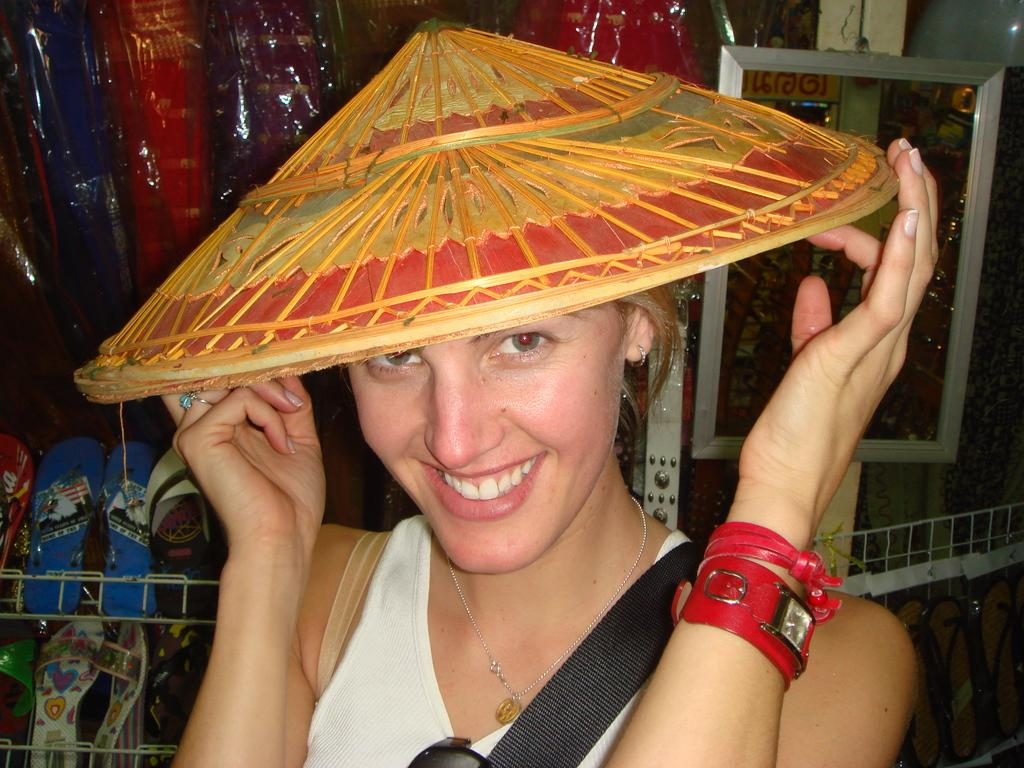Who is present in the image? There is a woman in the image. What is the woman wearing on her head? The woman is wearing a hat. What object can be used for self-reflection in the image? There is a mirror visible in the image. What type of furniture is present in the image? There are covers in the image, which suggests the presence of furniture. What type of footwear can be seen in the image? There are slippers on racks in the image. What type of ink can be seen on the woman's hand in the image? There is no ink visible on the woman's hand in the image. 